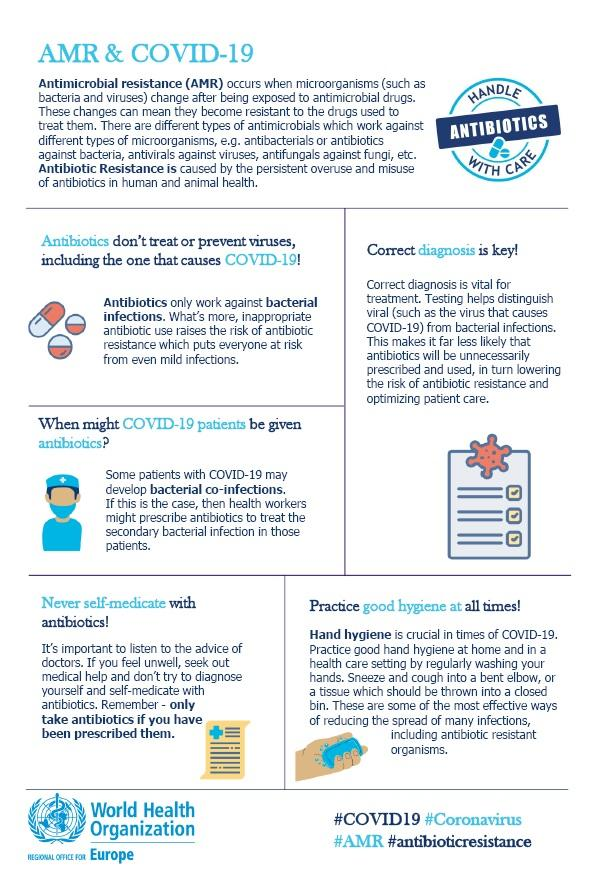Identify some key points in this picture. The anti-microbial drug commonly referred to as 'antibiotics' is a treatment option for bacterial infections. The anti-microbial drug used to treat viruses is known as an antivirus. Hand hygiene is the most effective practice in combating the Corona Virus. 